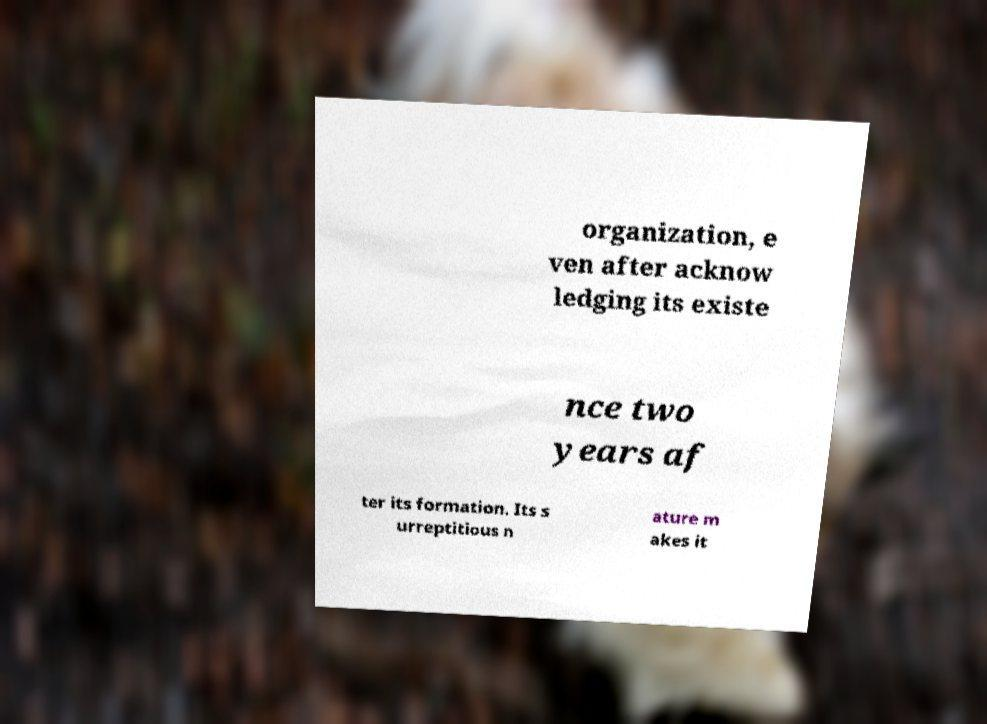Please identify and transcribe the text found in this image. organization, e ven after acknow ledging its existe nce two years af ter its formation. Its s urreptitious n ature m akes it 